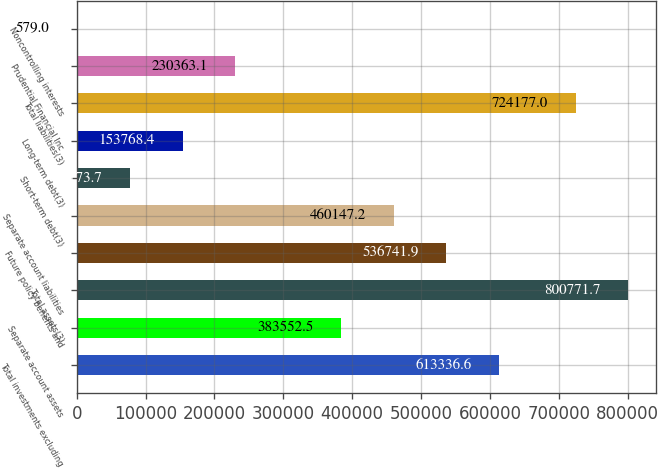<chart> <loc_0><loc_0><loc_500><loc_500><bar_chart><fcel>Total investments excluding<fcel>Separate account assets<fcel>Total assets(3)<fcel>Future policy benefits and<fcel>Separate account liabilities<fcel>Short-term debt(3)<fcel>Long-term debt(3)<fcel>Total liabilities(3)<fcel>Prudential Financial Inc<fcel>Noncontrolling interests<nl><fcel>613337<fcel>383552<fcel>800772<fcel>536742<fcel>460147<fcel>77173.7<fcel>153768<fcel>724177<fcel>230363<fcel>579<nl></chart> 